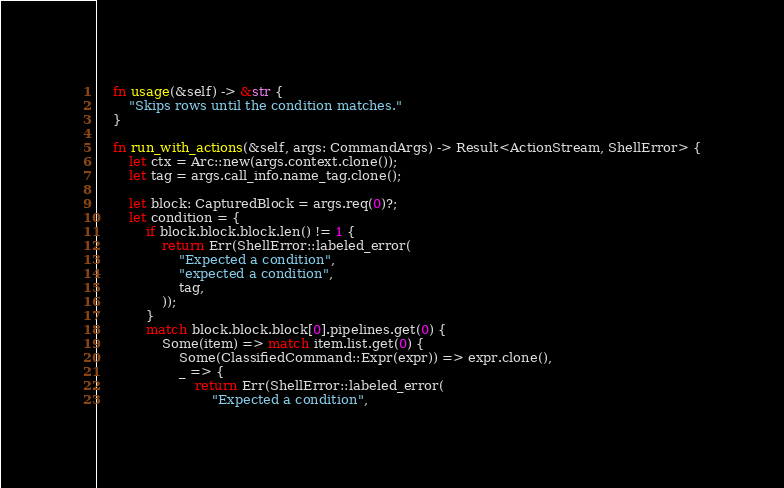Convert code to text. <code><loc_0><loc_0><loc_500><loc_500><_Rust_>    fn usage(&self) -> &str {
        "Skips rows until the condition matches."
    }

    fn run_with_actions(&self, args: CommandArgs) -> Result<ActionStream, ShellError> {
        let ctx = Arc::new(args.context.clone());
        let tag = args.call_info.name_tag.clone();

        let block: CapturedBlock = args.req(0)?;
        let condition = {
            if block.block.block.len() != 1 {
                return Err(ShellError::labeled_error(
                    "Expected a condition",
                    "expected a condition",
                    tag,
                ));
            }
            match block.block.block[0].pipelines.get(0) {
                Some(item) => match item.list.get(0) {
                    Some(ClassifiedCommand::Expr(expr)) => expr.clone(),
                    _ => {
                        return Err(ShellError::labeled_error(
                            "Expected a condition",</code> 